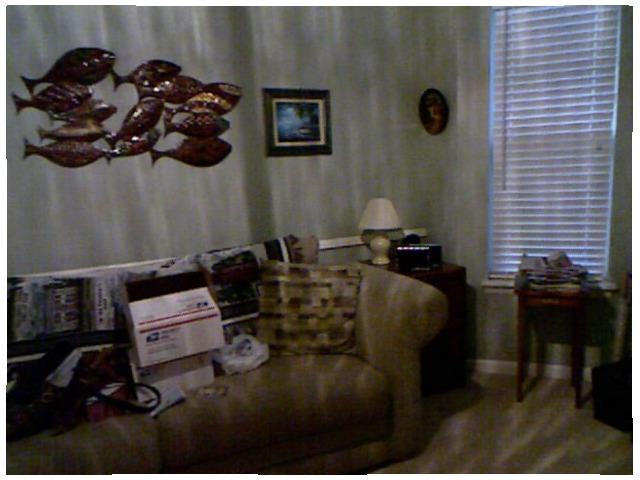<image>
Can you confirm if the picture is on the wall? Yes. Looking at the image, I can see the picture is positioned on top of the wall, with the wall providing support. Is there a box behind the frame? No. The box is not behind the frame. From this viewpoint, the box appears to be positioned elsewhere in the scene. Is there a fish next to the photo frame? Yes. The fish is positioned adjacent to the photo frame, located nearby in the same general area. 